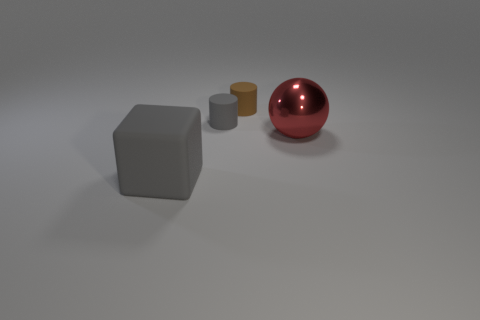There is a big thing that is behind the large gray rubber cube; what number of red metallic objects are in front of it?
Your response must be concise. 0. There is a block; is it the same color as the big thing that is behind the large rubber object?
Your answer should be compact. No. How many small brown objects have the same shape as the large rubber object?
Give a very brief answer. 0. What is the gray object in front of the gray rubber cylinder made of?
Provide a short and direct response. Rubber. There is a big thing that is to the right of the brown rubber thing; is its shape the same as the tiny brown object?
Offer a very short reply. No. Is there another red shiny object that has the same size as the red metal object?
Offer a very short reply. No. There is a big metallic thing; is it the same shape as the gray matte thing to the left of the small gray object?
Your answer should be very brief. No. Are there fewer large rubber things behind the brown rubber object than small brown blocks?
Offer a terse response. No. Does the brown object have the same shape as the small gray object?
Your answer should be compact. Yes. What size is the gray cube that is made of the same material as the tiny gray object?
Keep it short and to the point. Large. 